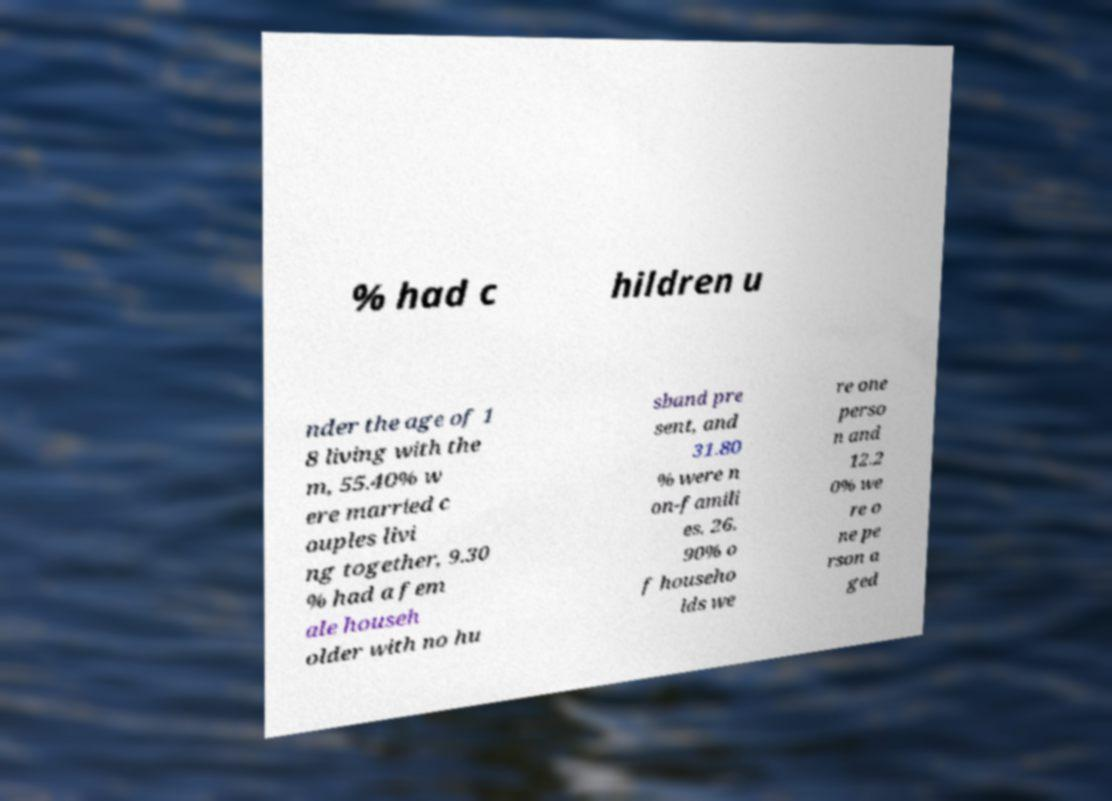I need the written content from this picture converted into text. Can you do that? % had c hildren u nder the age of 1 8 living with the m, 55.40% w ere married c ouples livi ng together, 9.30 % had a fem ale househ older with no hu sband pre sent, and 31.80 % were n on-famili es. 26. 90% o f househo lds we re one perso n and 12.2 0% we re o ne pe rson a ged 